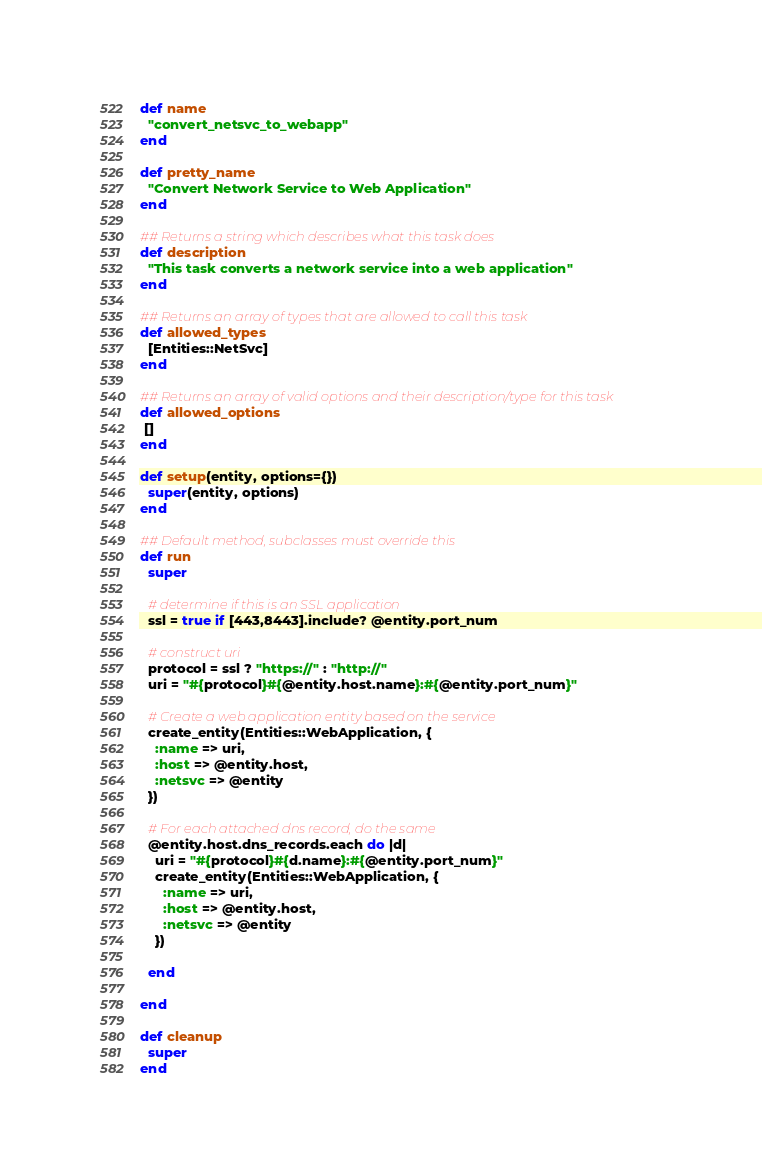<code> <loc_0><loc_0><loc_500><loc_500><_Ruby_>def name
  "convert_netsvc_to_webapp"
end

def pretty_name
  "Convert Network Service to Web Application"
end

## Returns a string which describes what this task does
def description
  "This task converts a network service into a web application"
end

## Returns an array of types that are allowed to call this task
def allowed_types
  [Entities::NetSvc]
end

## Returns an array of valid options and their description/type for this task
def allowed_options
 []
end

def setup(entity, options={})
  super(entity, options)
end

## Default method, subclasses must override this
def run
  super

  # determine if this is an SSL application
  ssl = true if [443,8443].include? @entity.port_num
  
  # construct uri
  protocol = ssl ? "https://" : "http://"
  uri = "#{protocol}#{@entity.host.name}:#{@entity.port_num}"

  # Create a web application entity based on the service
  create_entity(Entities::WebApplication, {
    :name => uri,
    :host => @entity.host,
    :netsvc => @entity
  })

  # For each attached dns record, do the same
  @entity.host.dns_records.each do |d|
    uri = "#{protocol}#{d.name}:#{@entity.port_num}"
    create_entity(Entities::WebApplication, {
      :name => uri,
      :host => @entity.host,
      :netsvc => @entity
    })

  end

end

def cleanup
  super
end
</code> 